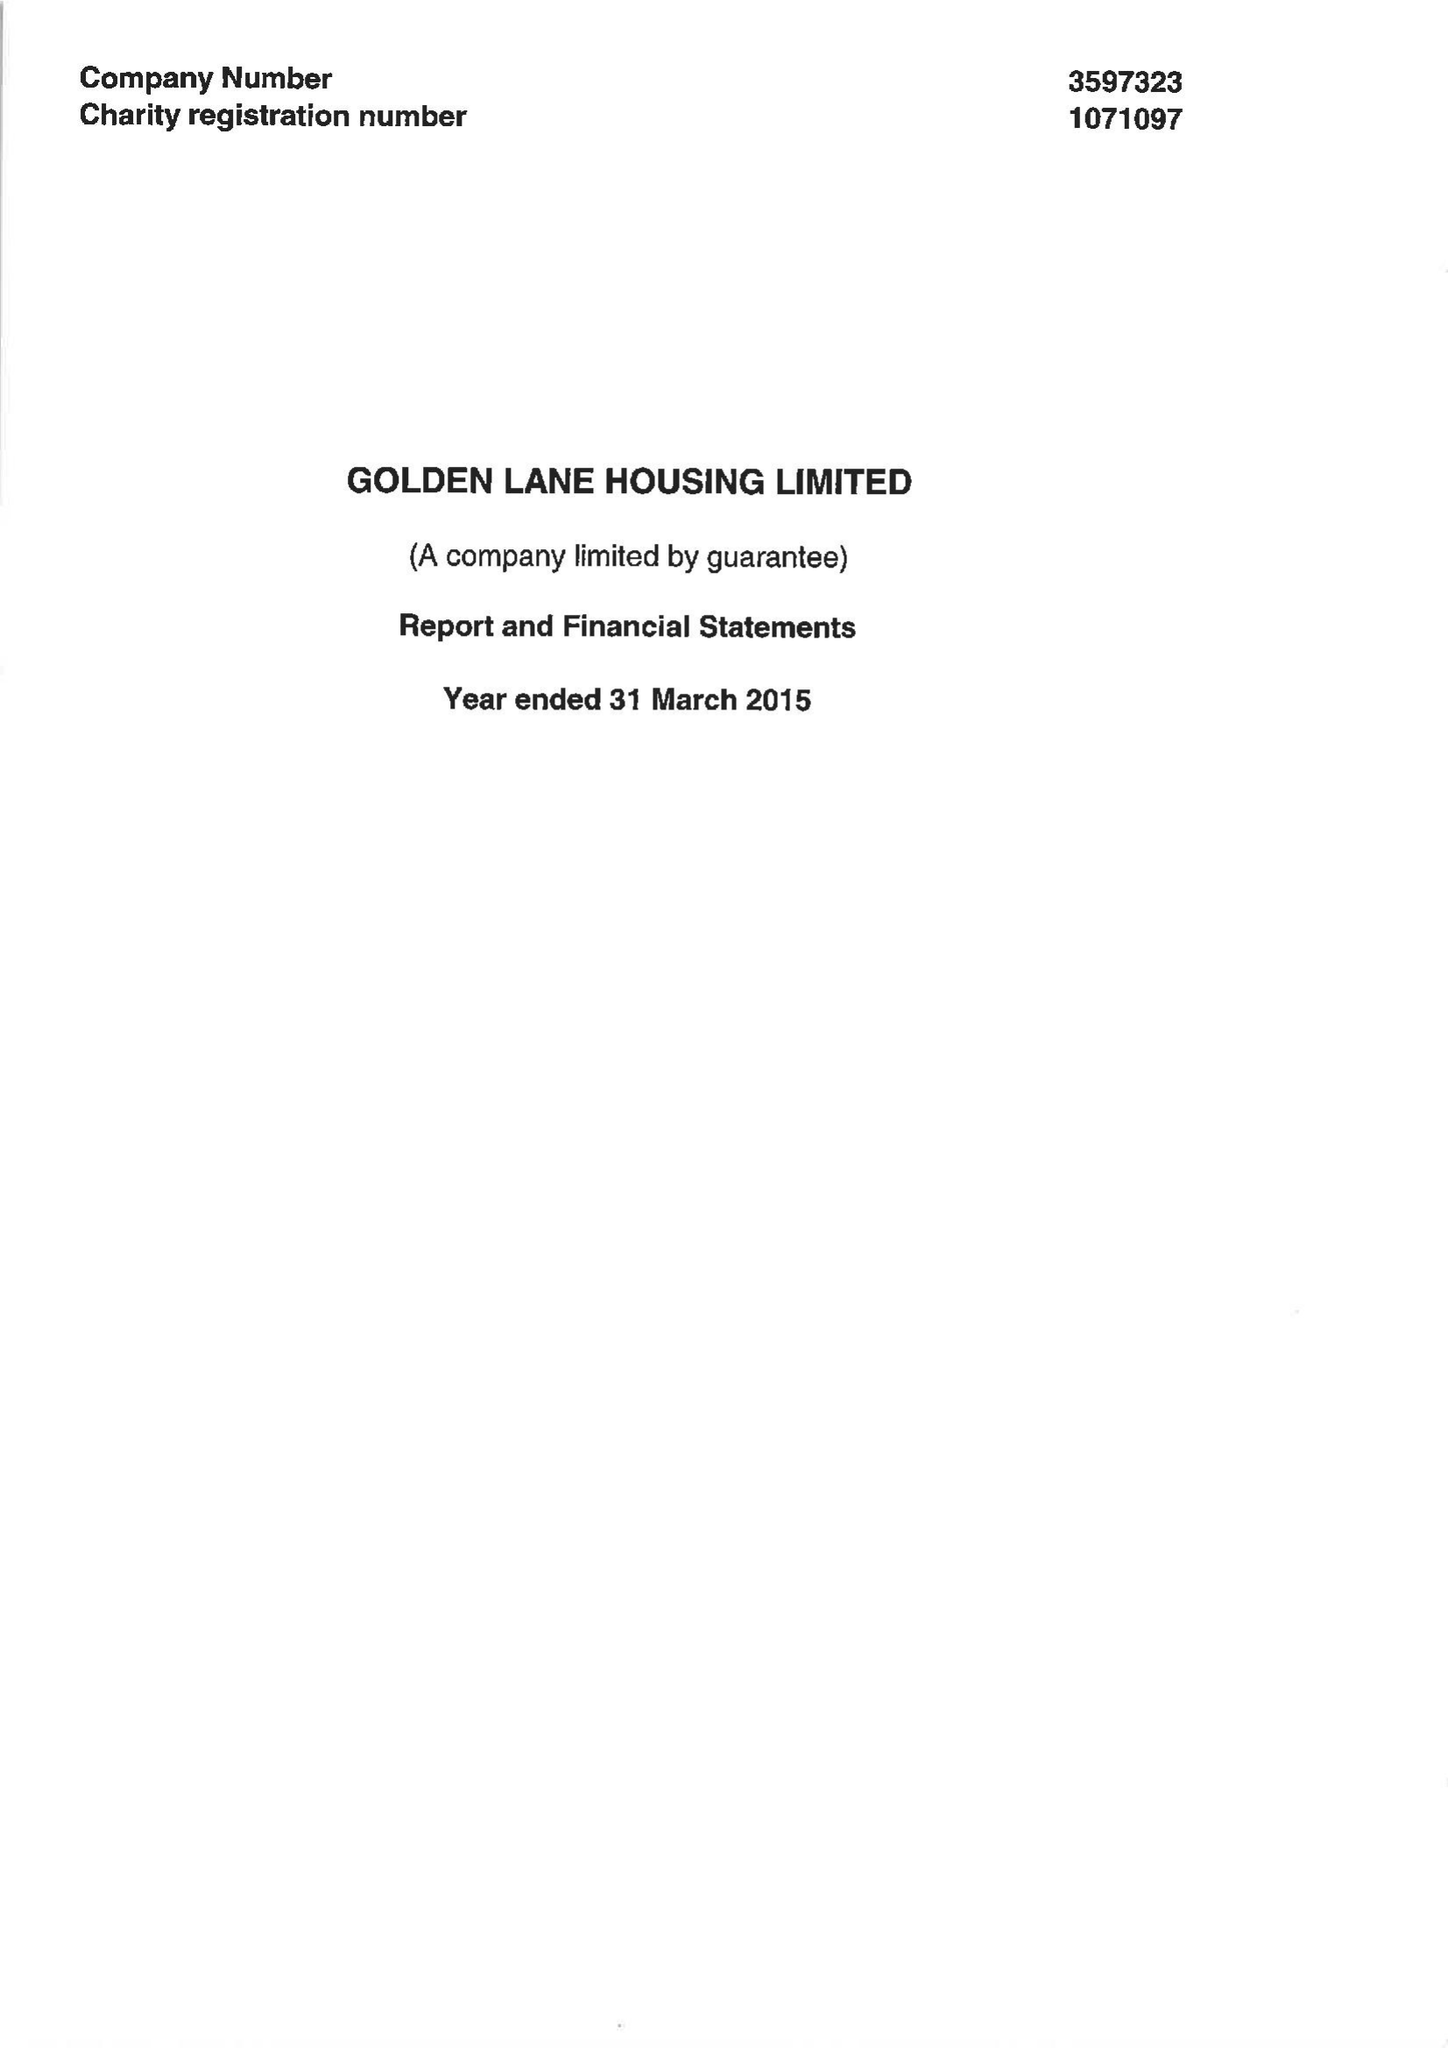What is the value for the address__postcode?
Answer the question using a single word or phrase. EC1Y 0RT 